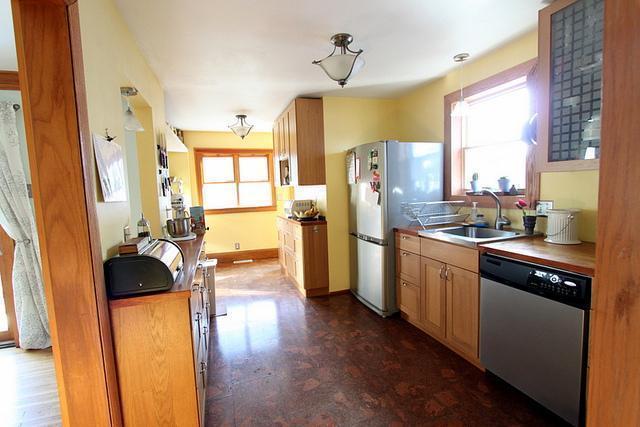What is the rolltop object used for?
From the following four choices, select the correct answer to address the question.
Options: Hold coffee, hold flour, bread box, paying bills. Bread box. 